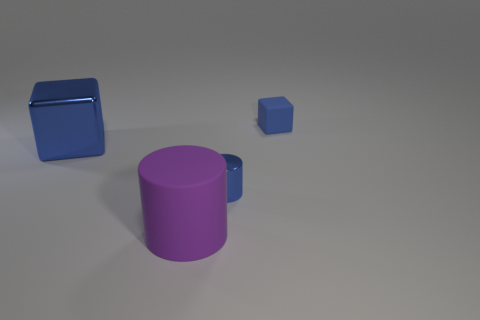What colors are present in the image, and how do they contribute to the overall mood or aesthetic? The image displays objects with distinct colors: purple, blue, and metallic, appearing against a neutral background. The cool color palette consisting of blues and purples can convey a sense of calm and order. These colors, along with the simplicity of the composition, contribute to a modern and minimalistic aesthetic. 